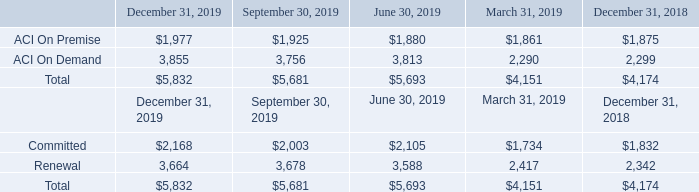The following table sets forth our 60-month backlog estimate, by reportable segment, as of December 31, 2019; September 30, 2019; June 30, 2019; March 31, 2019; and December 31, 2018 (in millions). The 60-month backlog estimate includes approximately $1.5 billion as a result of the acquisition of Speedpay, which occurred on May 9, 2019. Dollar amounts reflect foreign currency exchange rates as of each period end. This is a non-GAAP financial measure being presented to provide comparability across accounting periods. We believe this measure provides useful information to investors and others in understanding and evaluating our financial performance.
Estimates of future financial results require substantial judgment and are based on several assumptions, as described above. These assumptions may turn out to be inaccurate or wrong for reasons outside of management’s control. For example, our customers may attempt to renegotiate or terminate their contracts for many reasons, including mergers, changes in their financial condition, or general changes in economic conditions in the customer’s industry or geographic location. We may also experience delays in the development or delivery of products or services specified in customer contracts, which may cause the actual renewal rates and amounts to differ from historical experiences. Changes in foreign currency exchange rates may also impact the amount of revenue recognized in future periods. Accordingly, there can be no assurance that amounts included in backlog estimates will generate the specified revenues or that the actual revenues will be generated within the corresponding 60-month period. Additionally, because certain components of Committed Backlog and all of Renewal Backlog estimates are operating metrics, the estimates are not required to be subject to the same level of internal review or controls as contracted but not recognized Committed Backlog.
How much was the 60-month backlog estimate as a result of the acquisition of Speedpay?
Answer scale should be: billion. $1.5 billion. What was the committed backlog in December 31, 2019?
Answer scale should be: million. $2,168. What was the committed backlog in June 30, 2019?
Answer scale should be: million. $2,105. What was the difference in committed backlog between December 31 and September 30, 2019?
Answer scale should be: million. ($2,168-$2,003)
Answer: 165. What was the difference in Renewal backlog between June 30 and March 31, 2019?
Answer scale should be: million. 3,588-2,417
Answer: 1171. What was the percentage change in ACI on premise between December 31 and September 30, 2019?
Answer scale should be: percent. ($1,977-$1,925)/$1,925
Answer: 2.7. 